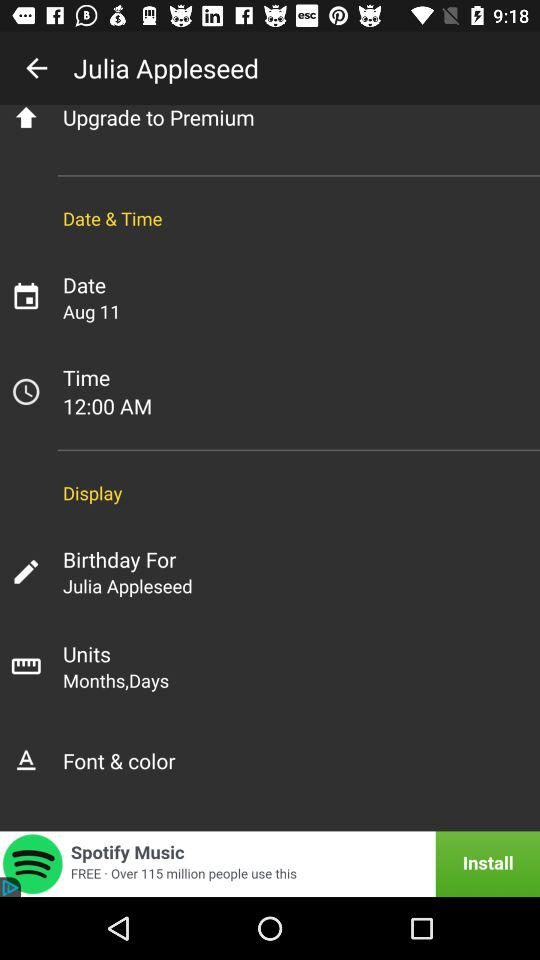What are the provided units? The provided units are months and days. 